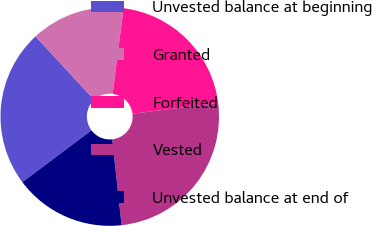Convert chart. <chart><loc_0><loc_0><loc_500><loc_500><pie_chart><fcel>Unvested balance at beginning<fcel>Granted<fcel>Forfeited<fcel>Vested<fcel>Unvested balance at end of<nl><fcel>23.37%<fcel>13.89%<fcel>21.0%<fcel>25.26%<fcel>16.48%<nl></chart> 